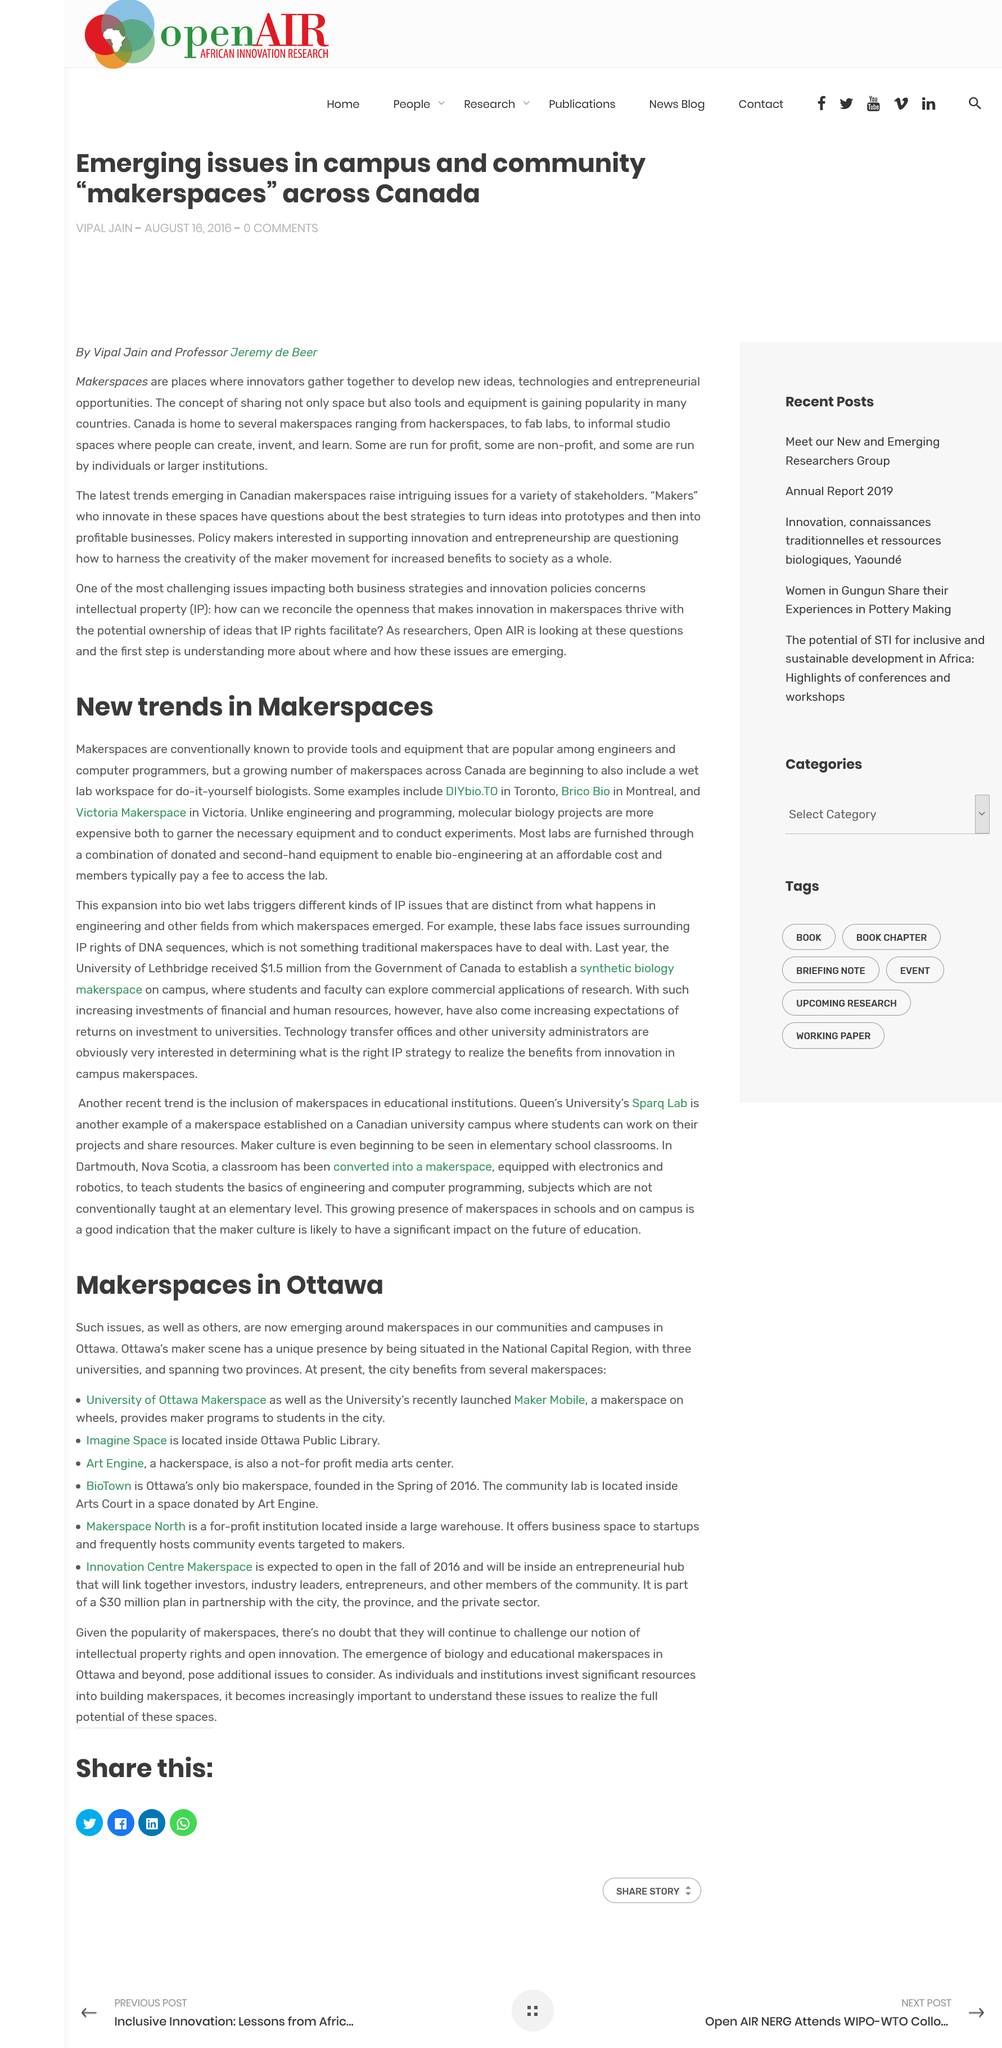Specify some key components in this picture. A wet lab workspace for DIY biologists is a new trend in Makerspaces. Brico Bio in Montreal is a makerspace that provides access to tools, equipment, and resources for people to create and experiment with biotechnology projects. It offers a collaborative environment for learning, experimenting, and building, and provides opportunities for people to work on their own projects and share their knowledge with others. Brico Bio is an example of a makerspace that focuses on biotechnology and serves as a model for similar spaces in other cities. Molecular biology projects are generally more expensive than those in engineering and programming due to the need for specialized equipment and resources. 